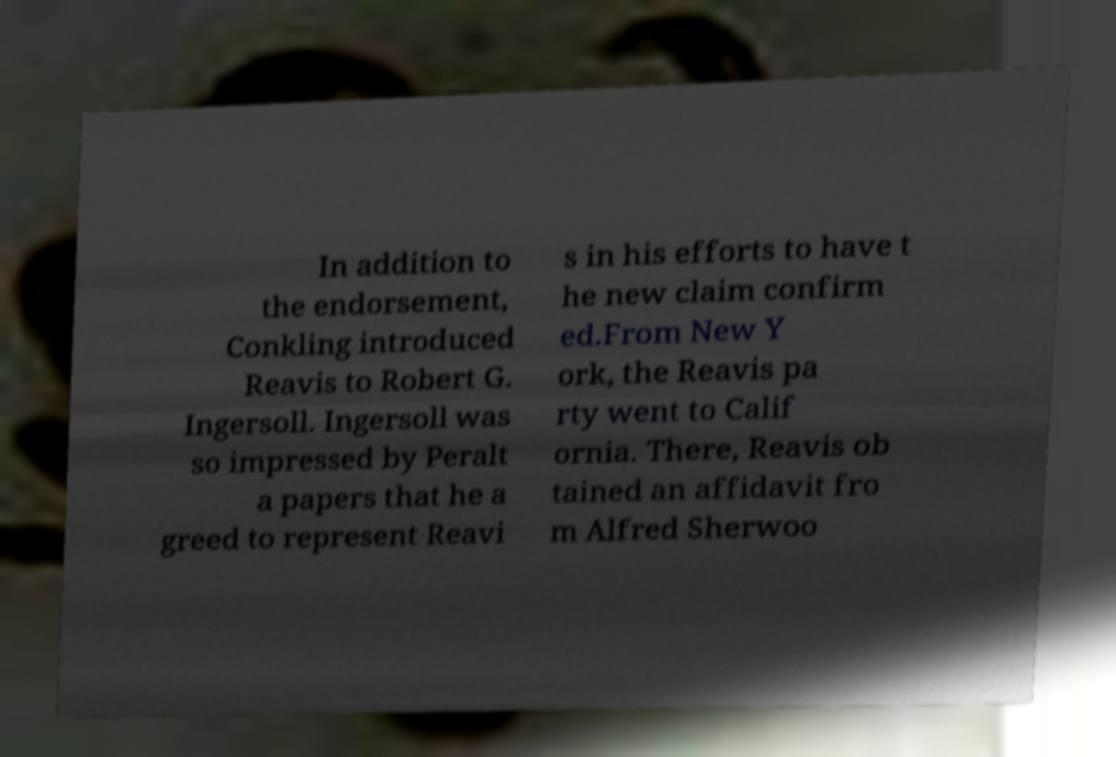Please read and relay the text visible in this image. What does it say? In addition to the endorsement, Conkling introduced Reavis to Robert G. Ingersoll. Ingersoll was so impressed by Peralt a papers that he a greed to represent Reavi s in his efforts to have t he new claim confirm ed.From New Y ork, the Reavis pa rty went to Calif ornia. There, Reavis ob tained an affidavit fro m Alfred Sherwoo 